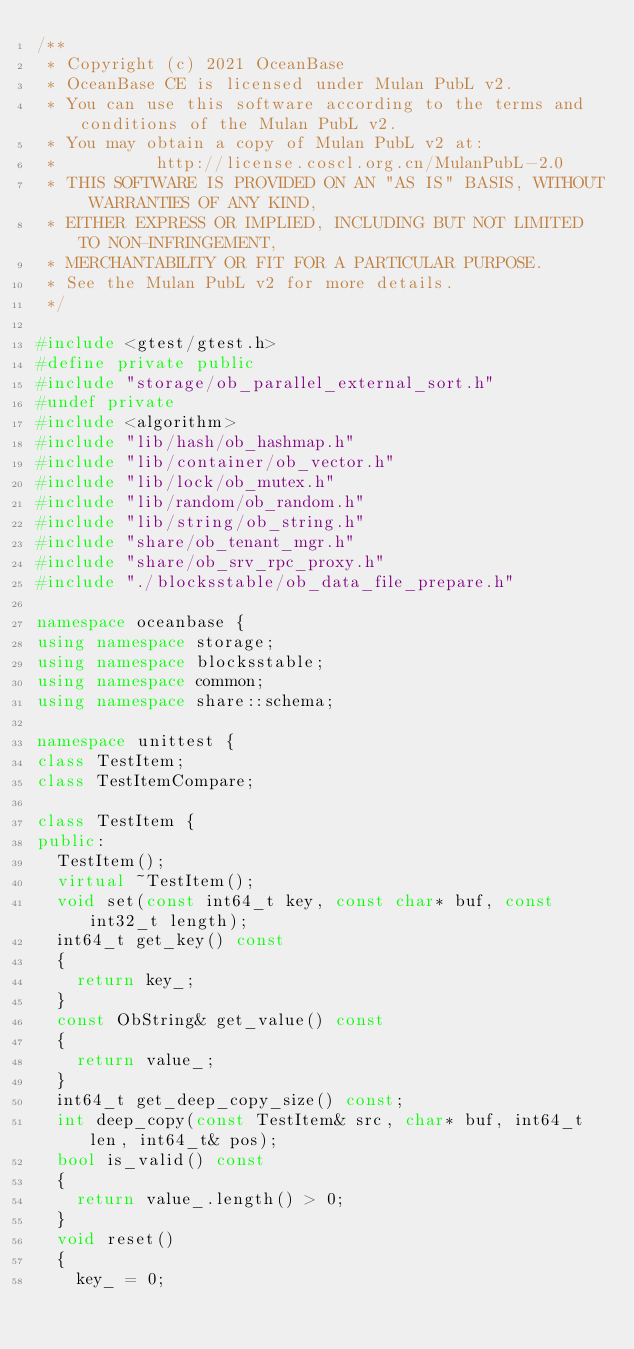<code> <loc_0><loc_0><loc_500><loc_500><_C++_>/**
 * Copyright (c) 2021 OceanBase
 * OceanBase CE is licensed under Mulan PubL v2.
 * You can use this software according to the terms and conditions of the Mulan PubL v2.
 * You may obtain a copy of Mulan PubL v2 at:
 *          http://license.coscl.org.cn/MulanPubL-2.0
 * THIS SOFTWARE IS PROVIDED ON AN "AS IS" BASIS, WITHOUT WARRANTIES OF ANY KIND,
 * EITHER EXPRESS OR IMPLIED, INCLUDING BUT NOT LIMITED TO NON-INFRINGEMENT,
 * MERCHANTABILITY OR FIT FOR A PARTICULAR PURPOSE.
 * See the Mulan PubL v2 for more details.
 */

#include <gtest/gtest.h>
#define private public
#include "storage/ob_parallel_external_sort.h"
#undef private
#include <algorithm>
#include "lib/hash/ob_hashmap.h"
#include "lib/container/ob_vector.h"
#include "lib/lock/ob_mutex.h"
#include "lib/random/ob_random.h"
#include "lib/string/ob_string.h"
#include "share/ob_tenant_mgr.h"
#include "share/ob_srv_rpc_proxy.h"
#include "./blocksstable/ob_data_file_prepare.h"

namespace oceanbase {
using namespace storage;
using namespace blocksstable;
using namespace common;
using namespace share::schema;

namespace unittest {
class TestItem;
class TestItemCompare;

class TestItem {
public:
  TestItem();
  virtual ~TestItem();
  void set(const int64_t key, const char* buf, const int32_t length);
  int64_t get_key() const
  {
    return key_;
  }
  const ObString& get_value() const
  {
    return value_;
  }
  int64_t get_deep_copy_size() const;
  int deep_copy(const TestItem& src, char* buf, int64_t len, int64_t& pos);
  bool is_valid() const
  {
    return value_.length() > 0;
  }
  void reset()
  {
    key_ = 0;</code> 